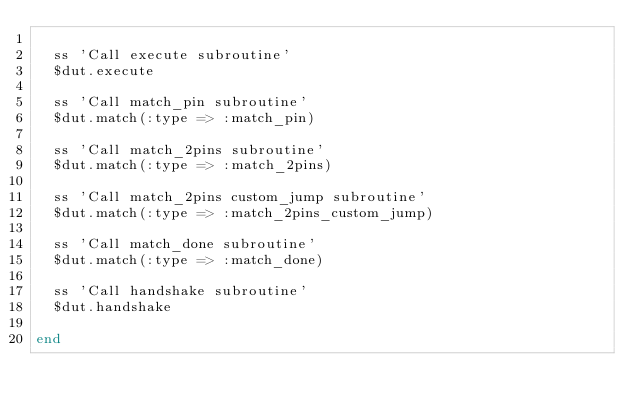Convert code to text. <code><loc_0><loc_0><loc_500><loc_500><_Ruby_>
  ss 'Call execute subroutine'
  $dut.execute

  ss 'Call match_pin subroutine'
  $dut.match(:type => :match_pin)

  ss 'Call match_2pins subroutine'
  $dut.match(:type => :match_2pins)

  ss 'Call match_2pins custom_jump subroutine'
  $dut.match(:type => :match_2pins_custom_jump)

  ss 'Call match_done subroutine'
  $dut.match(:type => :match_done)

  ss 'Call handshake subroutine'
  $dut.handshake

end
</code> 